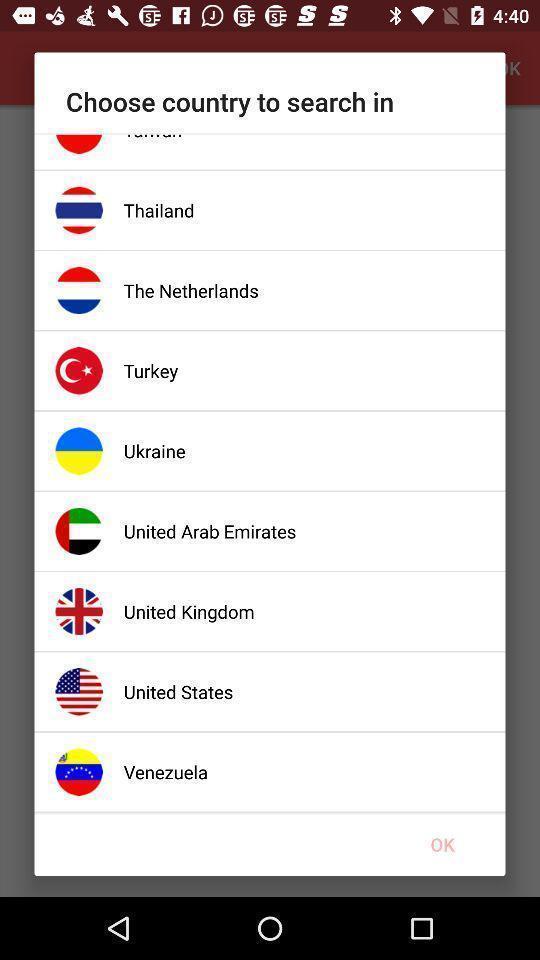What details can you identify in this image? Pop-up displaying different countries to choose. 